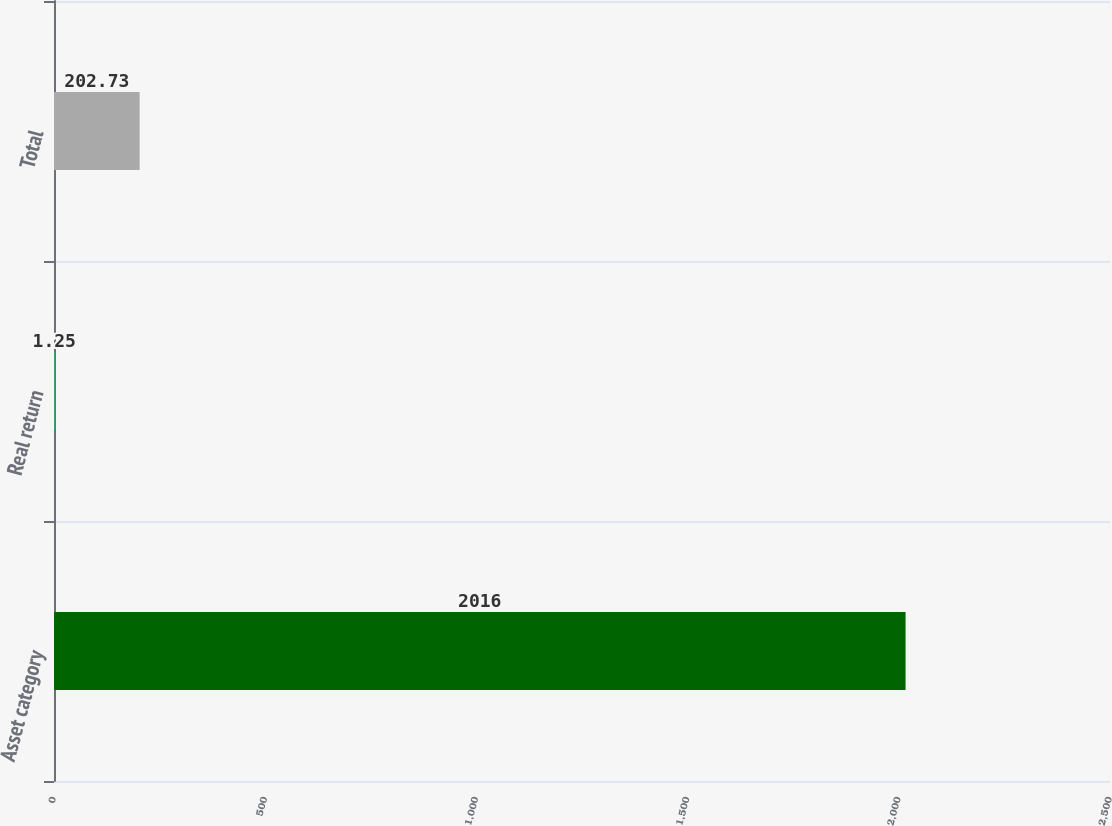Convert chart. <chart><loc_0><loc_0><loc_500><loc_500><bar_chart><fcel>Asset category<fcel>Real return<fcel>Total<nl><fcel>2016<fcel>1.25<fcel>202.73<nl></chart> 